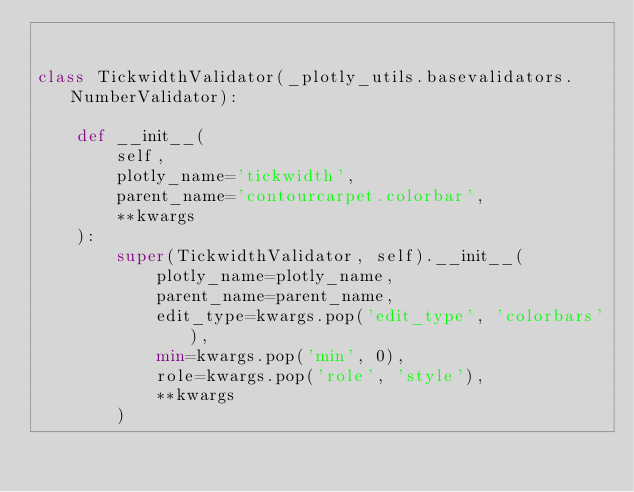Convert code to text. <code><loc_0><loc_0><loc_500><loc_500><_Python_>

class TickwidthValidator(_plotly_utils.basevalidators.NumberValidator):

    def __init__(
        self,
        plotly_name='tickwidth',
        parent_name='contourcarpet.colorbar',
        **kwargs
    ):
        super(TickwidthValidator, self).__init__(
            plotly_name=plotly_name,
            parent_name=parent_name,
            edit_type=kwargs.pop('edit_type', 'colorbars'),
            min=kwargs.pop('min', 0),
            role=kwargs.pop('role', 'style'),
            **kwargs
        )
</code> 